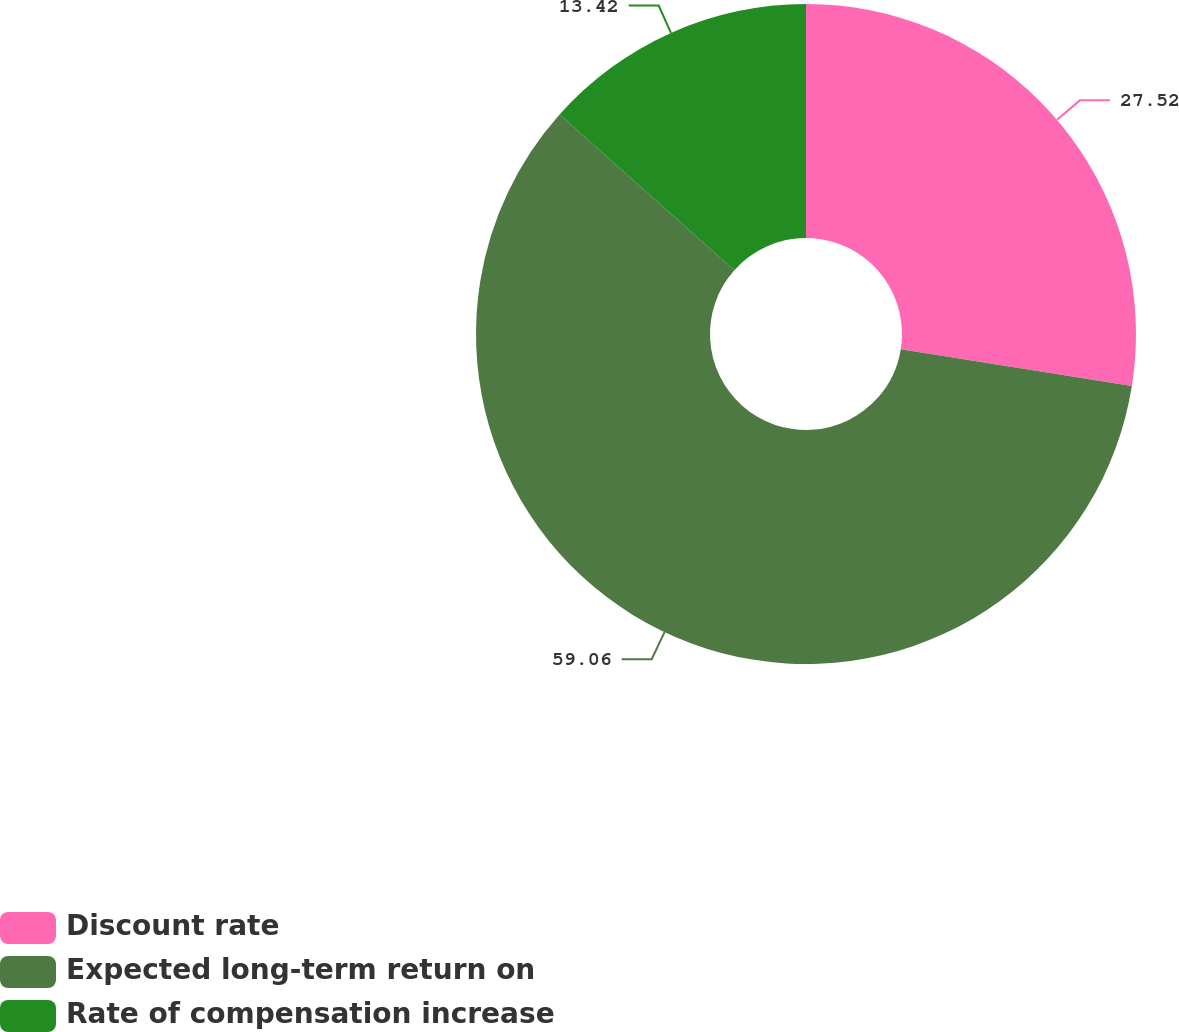Convert chart to OTSL. <chart><loc_0><loc_0><loc_500><loc_500><pie_chart><fcel>Discount rate<fcel>Expected long-term return on<fcel>Rate of compensation increase<nl><fcel>27.52%<fcel>59.06%<fcel>13.42%<nl></chart> 